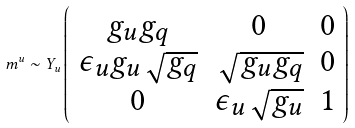<formula> <loc_0><loc_0><loc_500><loc_500>m ^ { u } \sim Y _ { u } \left ( \begin{array} { c c c } g _ { u } g _ { q } & 0 & 0 \\ \epsilon _ { u } g _ { u } \sqrt { g _ { q } } & \sqrt { g _ { u } g _ { q } } & 0 \\ 0 & \epsilon _ { u } \sqrt { g _ { u } } & 1 \end{array} \right )</formula> 